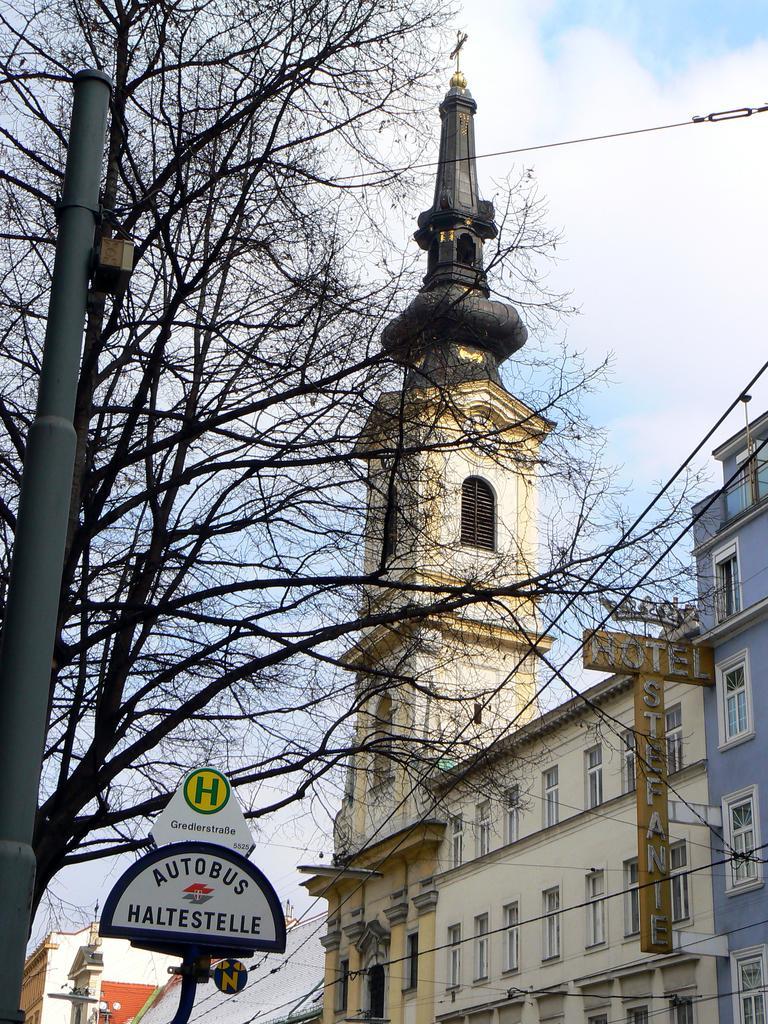Describe this image in one or two sentences. There is a tree and a pole on the left side of the image and a sign pole at the bottom side. There are buildings, wire and the sky in the background. 